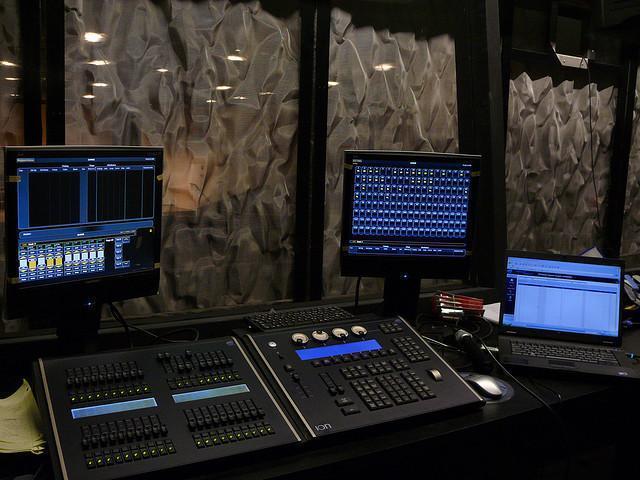How many tvs are visible?
Give a very brief answer. 2. 